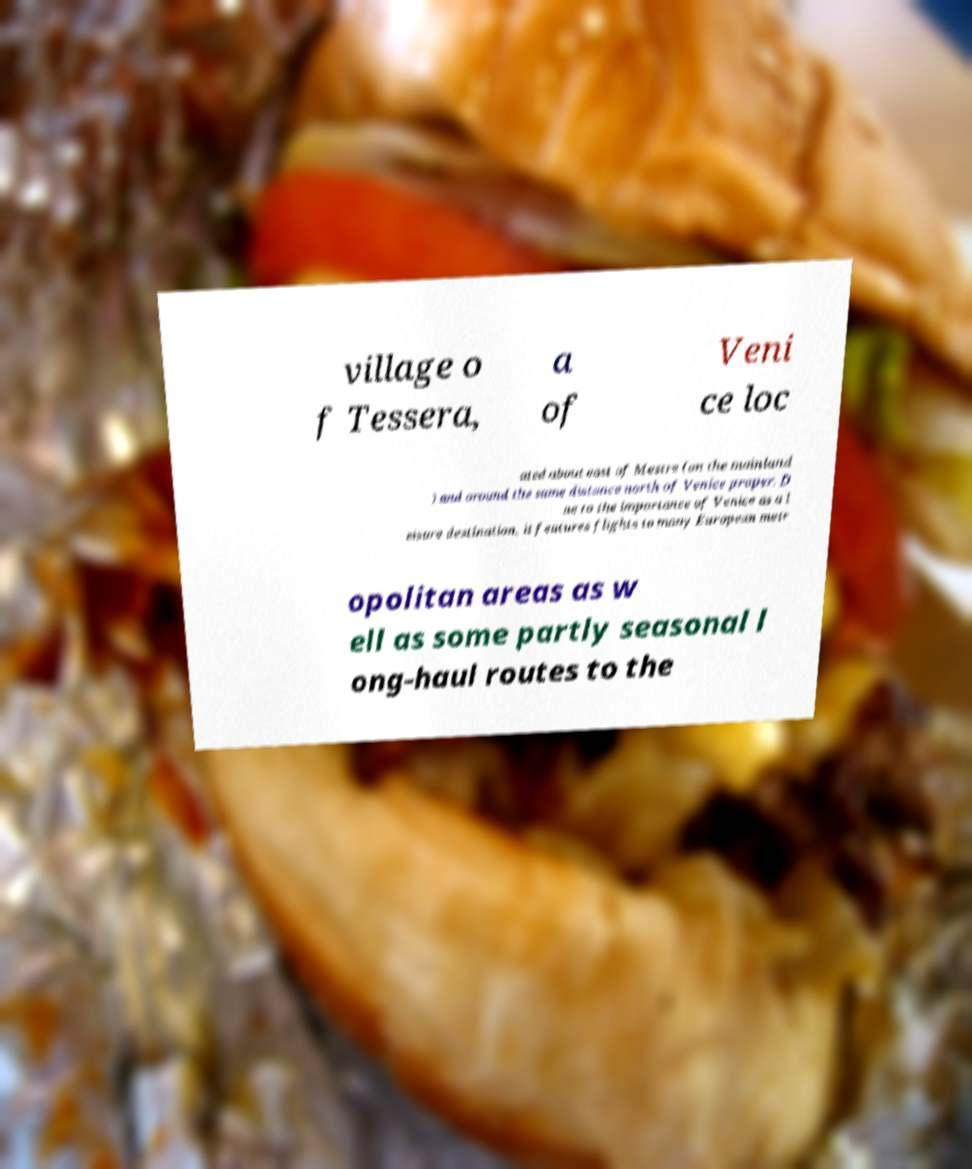Please identify and transcribe the text found in this image. village o f Tessera, a of Veni ce loc ated about east of Mestre (on the mainland ) and around the same distance north of Venice proper. D ue to the importance of Venice as a l eisure destination, it features flights to many European metr opolitan areas as w ell as some partly seasonal l ong-haul routes to the 